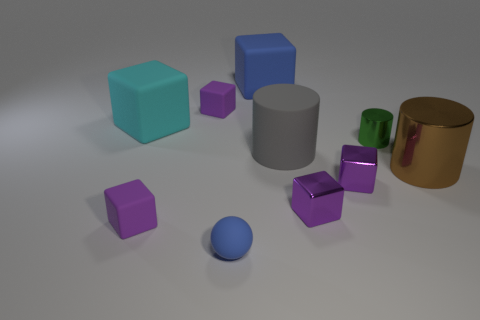What size is the object that is the same color as the tiny rubber ball?
Your answer should be very brief. Large. What is the shape of the blue rubber thing that is in front of the large matte object that is on the left side of the blue rubber cube?
Ensure brevity in your answer.  Sphere. Does the brown shiny thing have the same shape as the tiny matte thing behind the large brown thing?
Your response must be concise. No. What color is the other cube that is the same size as the blue cube?
Your answer should be compact. Cyan. Is the number of cylinders in front of the tiny green metal cylinder less than the number of small things that are behind the small rubber ball?
Provide a short and direct response. Yes. There is a blue object on the left side of the blue matte object right of the blue thing left of the large blue block; what shape is it?
Give a very brief answer. Sphere. Does the small rubber object that is behind the cyan cube have the same color as the tiny matte cube that is in front of the green shiny cylinder?
Give a very brief answer. Yes. What number of metal things are either tiny purple cubes or large cubes?
Offer a very short reply. 2. What color is the large matte thing that is on the left side of the tiny rubber object in front of the tiny purple matte cube in front of the large rubber cylinder?
Your answer should be very brief. Cyan. What color is the other large thing that is the same shape as the large gray rubber object?
Offer a terse response. Brown. 